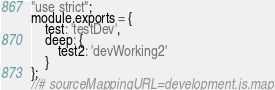<code> <loc_0><loc_0><loc_500><loc_500><_JavaScript_>"use strict";
module.exports = {
    test: 'testDev',
    deep: {
        test2: 'devWorking2'
    }
};
//# sourceMappingURL=development.js.map</code> 